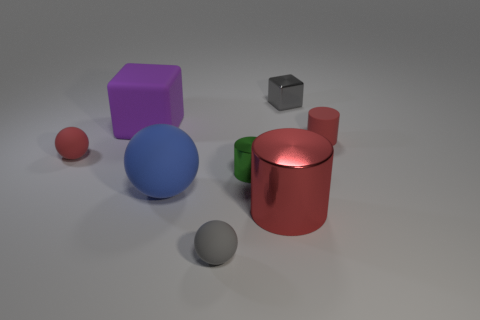There is a green metal object that is the same size as the gray rubber object; what shape is it?
Offer a terse response. Cylinder. What number of objects are either tiny objects right of the small gray sphere or large blue matte objects?
Provide a short and direct response. 4. How many other objects are the same material as the gray block?
Provide a short and direct response. 2. The small rubber thing that is the same color as the tiny cube is what shape?
Offer a very short reply. Sphere. There is a gray thing in front of the red matte sphere; what is its size?
Offer a terse response. Small. What shape is the big object that is the same material as the large sphere?
Your answer should be very brief. Cube. Are the red sphere and the tiny gray object that is in front of the tiny red matte cylinder made of the same material?
Your response must be concise. Yes. There is a tiny red matte object right of the big red cylinder; does it have the same shape as the large shiny object?
Your answer should be compact. Yes. There is a small gray thing that is the same shape as the large purple thing; what is it made of?
Provide a short and direct response. Metal. There is a large blue rubber object; is its shape the same as the tiny matte thing in front of the red metallic thing?
Keep it short and to the point. Yes. 